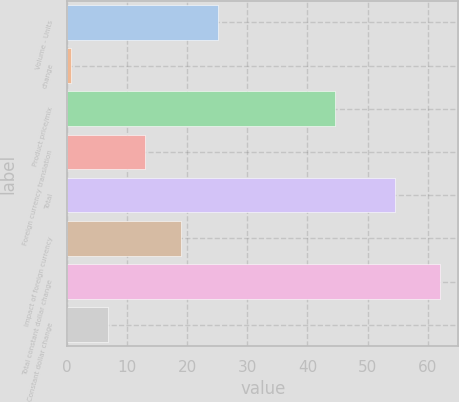<chart> <loc_0><loc_0><loc_500><loc_500><bar_chart><fcel>Volume - Units<fcel>change<fcel>Product price/mix<fcel>Foreign currency translation<fcel>Total<fcel>Impact of foreign currency<fcel>Total constant dollar change<fcel>Constant dollar change<nl><fcel>25.16<fcel>0.6<fcel>44.5<fcel>12.88<fcel>54.5<fcel>19.02<fcel>62<fcel>6.74<nl></chart> 